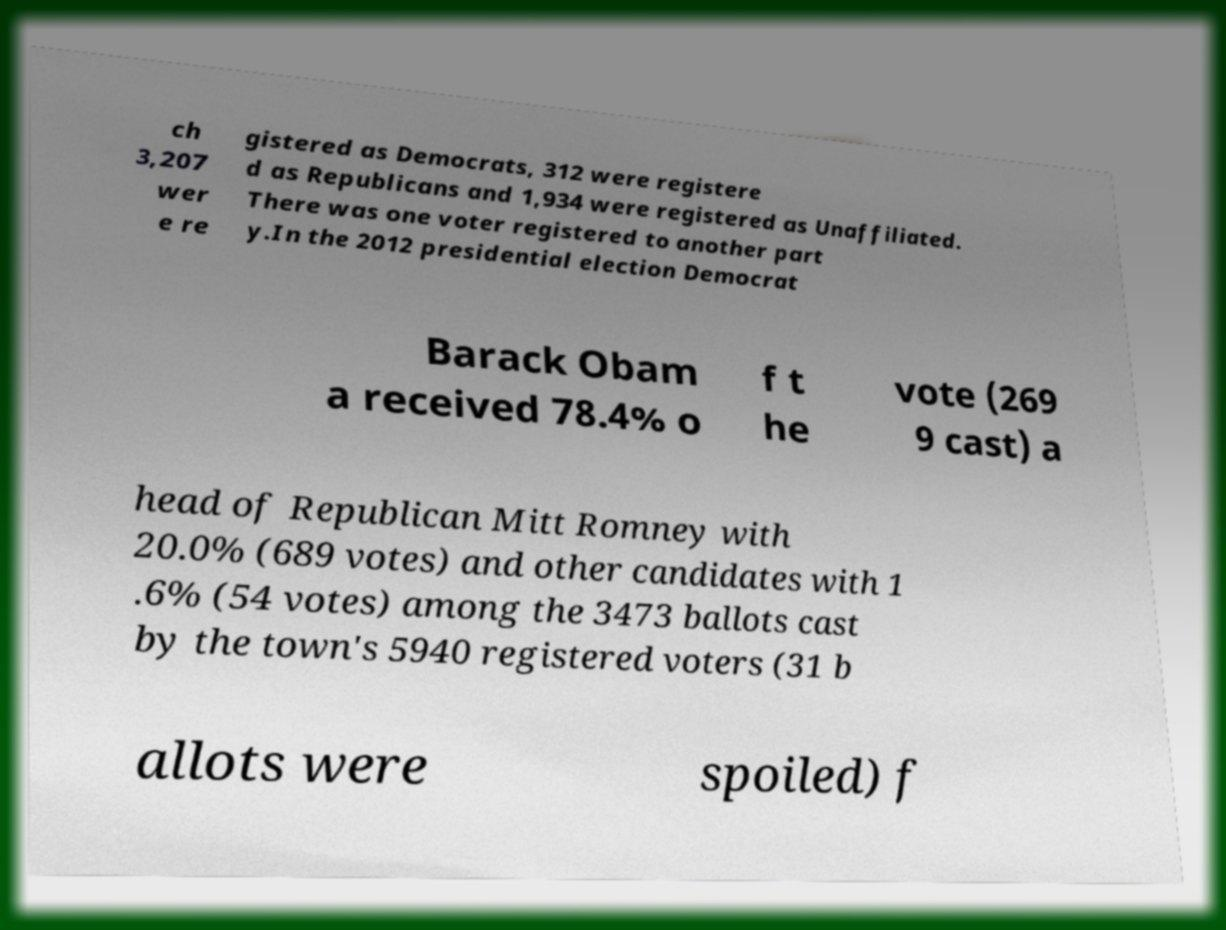For documentation purposes, I need the text within this image transcribed. Could you provide that? ch 3,207 wer e re gistered as Democrats, 312 were registere d as Republicans and 1,934 were registered as Unaffiliated. There was one voter registered to another part y.In the 2012 presidential election Democrat Barack Obam a received 78.4% o f t he vote (269 9 cast) a head of Republican Mitt Romney with 20.0% (689 votes) and other candidates with 1 .6% (54 votes) among the 3473 ballots cast by the town's 5940 registered voters (31 b allots were spoiled) f 